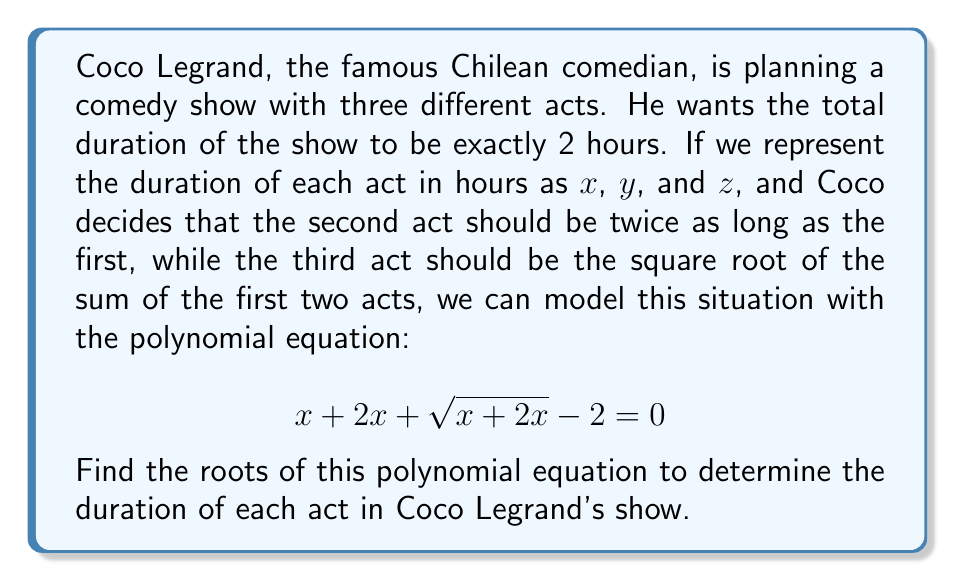Show me your answer to this math problem. Let's solve this step-by-step:

1) First, let's simplify the equation by substituting $x + 2x = 3x$:

   $$ 3x + \sqrt{3x} - 2 = 0 $$

2) To solve this, let's substitute $\sqrt{3x} = u$. This means $3x = u^2$:

   $$ u^2 + u - 2 = 0 $$

3) This is now a quadratic equation in $u$. We can solve it using the quadratic formula:

   $$ u = \frac{-b \pm \sqrt{b^2 - 4ac}}{2a} $$

   Where $a = 1$, $b = 1$, and $c = -2$

4) Substituting these values:

   $$ u = \frac{-1 \pm \sqrt{1^2 - 4(1)(-2)}}{2(1)} = \frac{-1 \pm \sqrt{9}}{2} = \frac{-1 \pm 3}{2} $$

5) This gives us two solutions for $u$:

   $$ u_1 = \frac{-1 + 3}{2} = 1 \quad \text{and} \quad u_2 = \frac{-1 - 3}{2} = -2 $$

6) Since $u$ represents $\sqrt{3x}$, and $x$ represents time which can't be negative, we can discard the negative solution. So:

   $$ \sqrt{3x} = 1 $$

7) Squaring both sides:

   $$ 3x = 1 $$

8) Solving for $x$:

   $$ x = \frac{1}{3} $$

9) Remember, $x$ represents the duration of the first act in hours. The second act is twice as long, so it's $\frac{2}{3}$ hours. The third act is $\sqrt{x + 2x} = \sqrt{3x} = 1$ hour.
Answer: The roots of the polynomial equation are:
First act: $x = \frac{1}{3}$ hours (20 minutes)
Second act: $y = \frac{2}{3}$ hours (40 minutes)
Third act: $z = 1$ hour (60 minutes) 